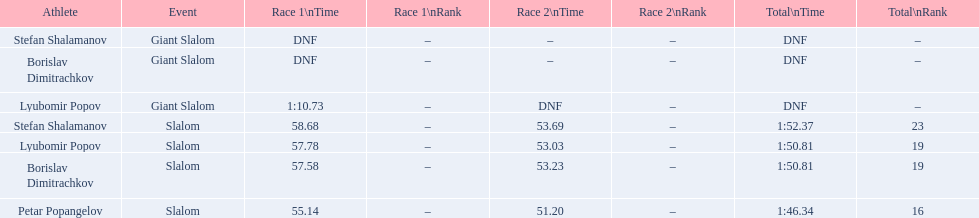Which event is the giant slalom? Giant Slalom, Giant Slalom, Giant Slalom. Which one is lyubomir popov? Lyubomir Popov. What is race 1 tim? 1:10.73. 